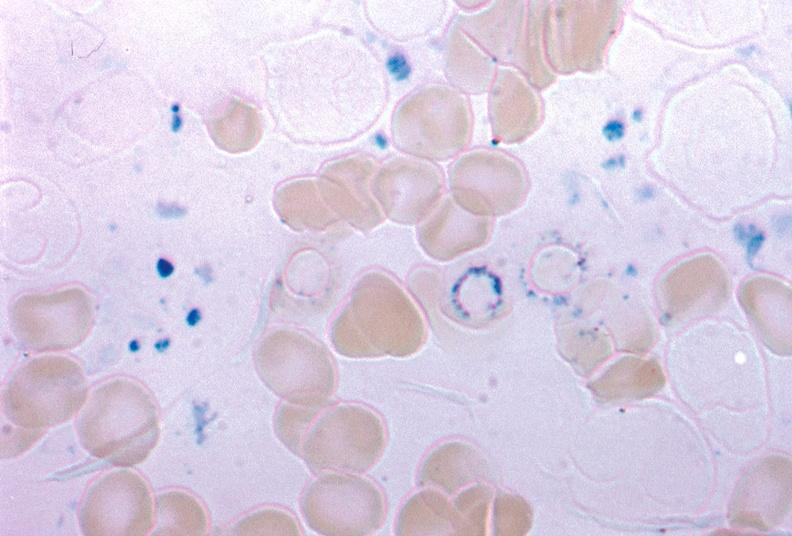what does this image show?
Answer the question using a single word or phrase. Iron stain excellent example source unknown 